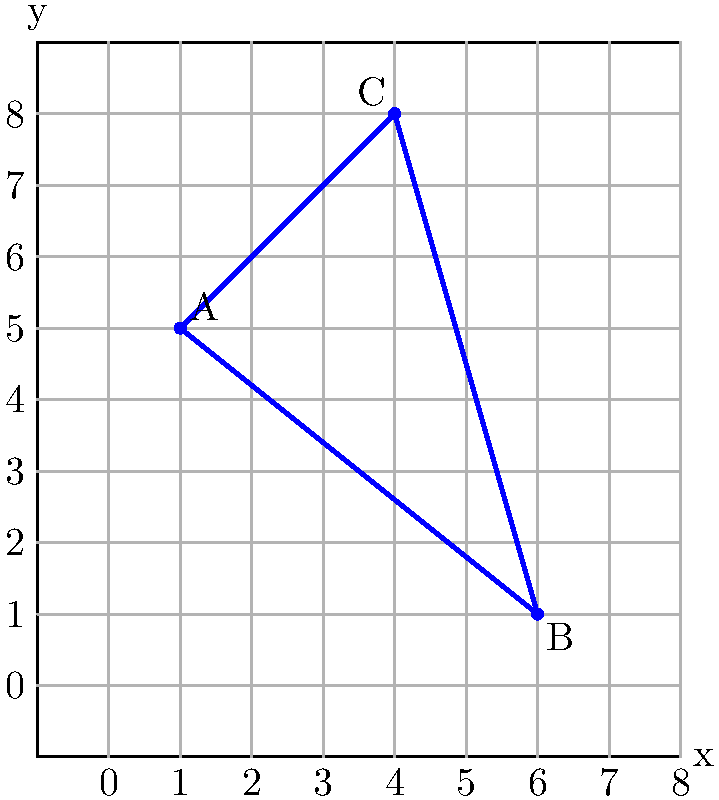In the ultimate '90s teen drama lockers scene, three best friends - Angela, Rayanne, and Sharon - discover their lockers form a perfect triangle in the school hallway. If their lockers are represented by points A(1,5), B(6,1), and C(4,8) on a coordinate grid, what is the area of the triangular space formed by their lockers? Let's approach this step-by-step, just like how Angela would methodically solve her problems in "My So-Called Life":

1) To find the area of a triangle given the coordinates of its vertices, we can use the formula:

   Area = $\frac{1}{2}|x_1(y_2 - y_3) + x_2(y_3 - y_1) + x_3(y_1 - y_2)|$

   Where $(x_1, y_1)$, $(x_2, y_2)$, and $(x_3, y_3)$ are the coordinates of the three vertices.

2) We have:
   A(1,5), B(6,1), C(4,8)
   
   So, $x_1 = 1$, $y_1 = 5$
       $x_2 = 6$, $y_2 = 1$
       $x_3 = 4$, $y_3 = 8$

3) Let's substitute these into our formula:

   Area = $\frac{1}{2}|1(1 - 8) + 6(8 - 5) + 4(5 - 1)|$

4) Let's solve the operations inside the parentheses:

   Area = $\frac{1}{2}|1(-7) + 6(3) + 4(4)|$

5) Now multiply:

   Area = $\frac{1}{2}|-7 + 18 + 16|$

6) Add inside the absolute value signs:

   Area = $\frac{1}{2}|27|$

7) The absolute value of 27 is 27, so:

   Area = $\frac{1}{2}(27) = 13.5$

Therefore, the area of the triangle is 13.5 square units.
Answer: 13.5 square units 